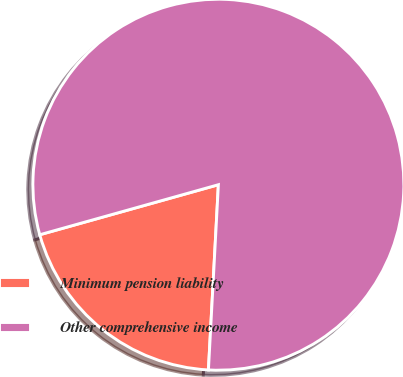<chart> <loc_0><loc_0><loc_500><loc_500><pie_chart><fcel>Minimum pension liability<fcel>Other comprehensive income<nl><fcel>19.8%<fcel>80.2%<nl></chart> 